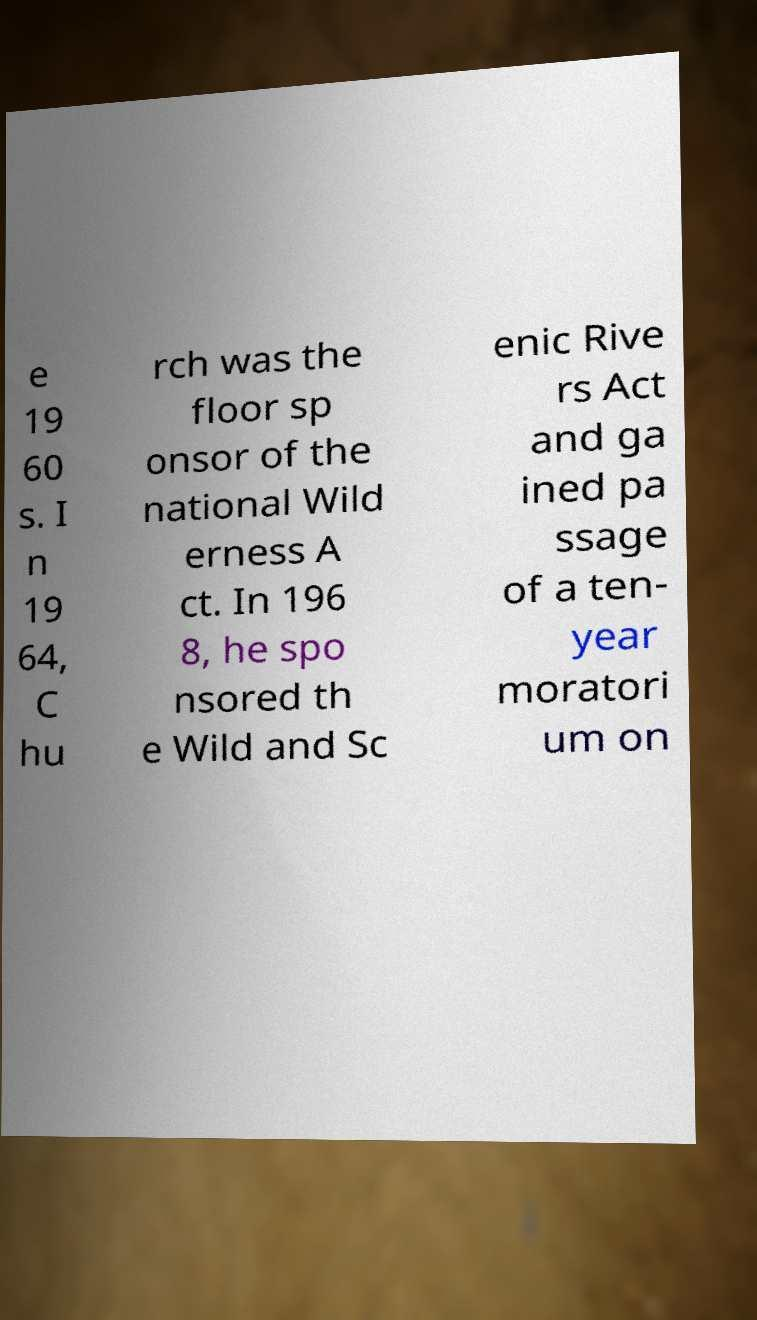For documentation purposes, I need the text within this image transcribed. Could you provide that? e 19 60 s. I n 19 64, C hu rch was the floor sp onsor of the national Wild erness A ct. In 196 8, he spo nsored th e Wild and Sc enic Rive rs Act and ga ined pa ssage of a ten- year moratori um on 